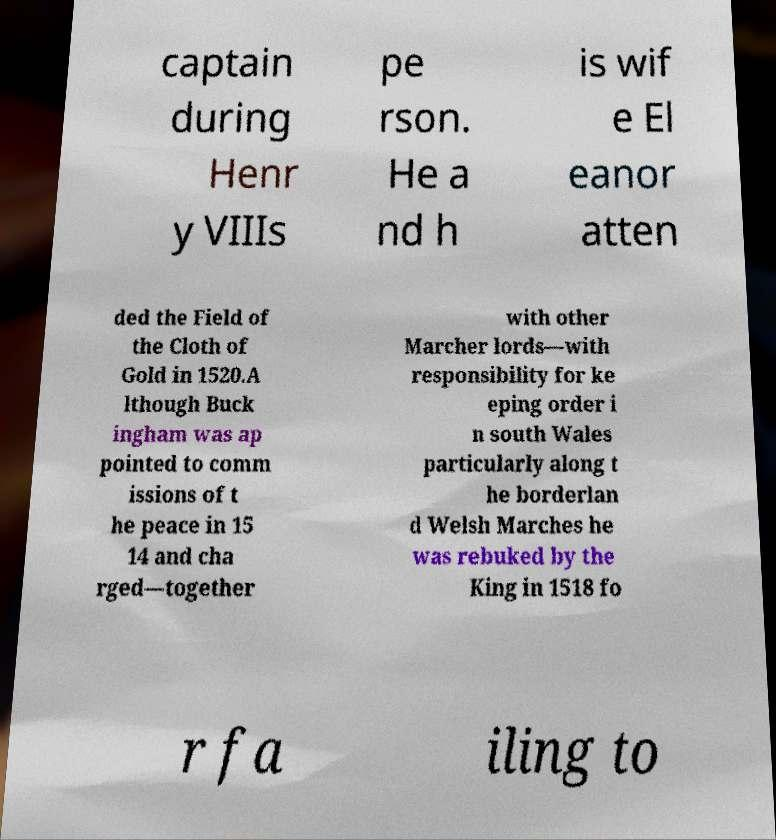Can you accurately transcribe the text from the provided image for me? captain during Henr y VIIIs pe rson. He a nd h is wif e El eanor atten ded the Field of the Cloth of Gold in 1520.A lthough Buck ingham was ap pointed to comm issions of t he peace in 15 14 and cha rged—together with other Marcher lords—with responsibility for ke eping order i n south Wales particularly along t he borderlan d Welsh Marches he was rebuked by the King in 1518 fo r fa iling to 